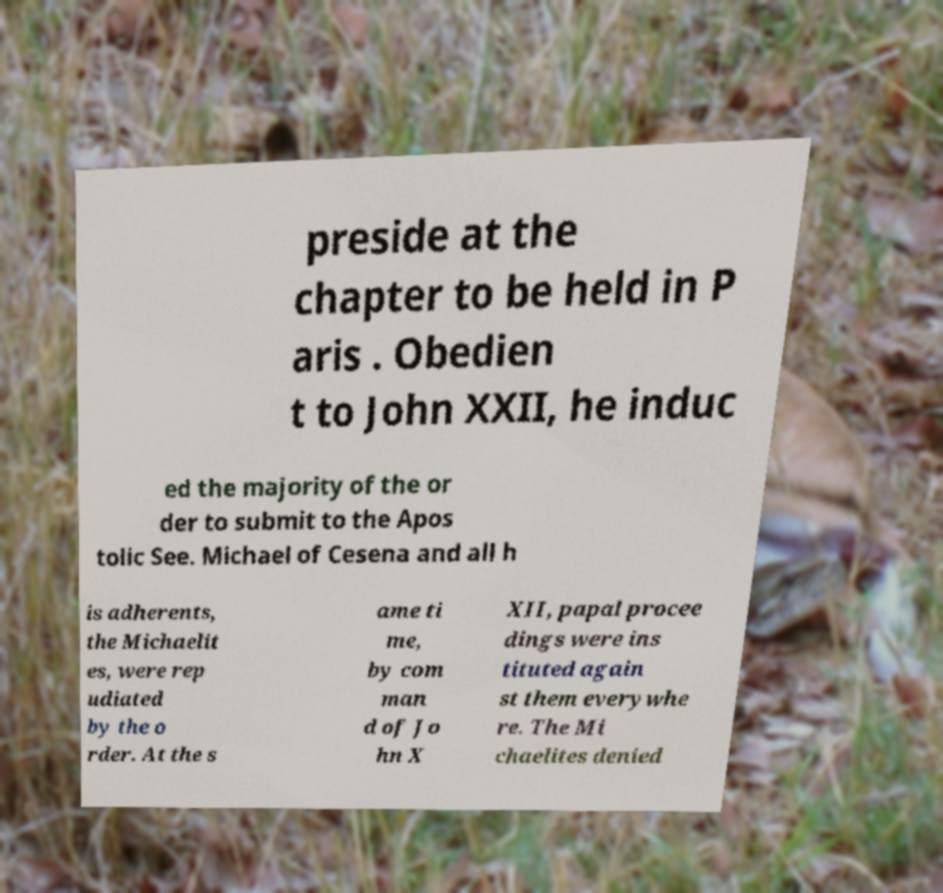What messages or text are displayed in this image? I need them in a readable, typed format. preside at the chapter to be held in P aris . Obedien t to John XXII, he induc ed the majority of the or der to submit to the Apos tolic See. Michael of Cesena and all h is adherents, the Michaelit es, were rep udiated by the o rder. At the s ame ti me, by com man d of Jo hn X XII, papal procee dings were ins tituted again st them everywhe re. The Mi chaelites denied 